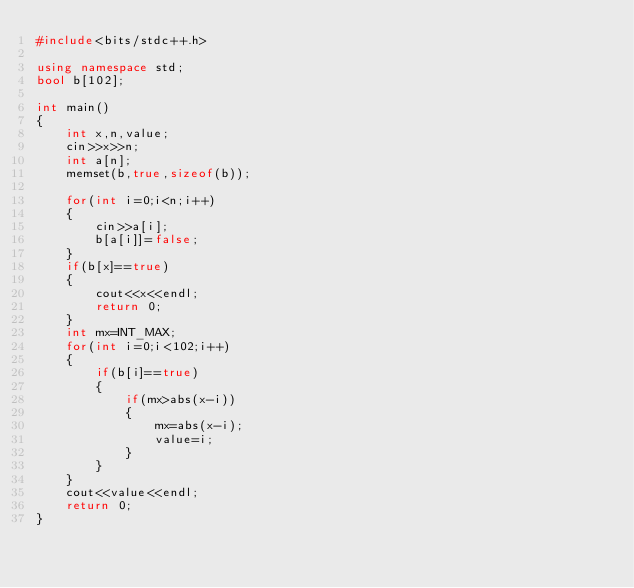<code> <loc_0><loc_0><loc_500><loc_500><_C++_>#include<bits/stdc++.h>

using namespace std;
bool b[102];

int main()
{
    int x,n,value;
    cin>>x>>n;
    int a[n];
    memset(b,true,sizeof(b));

    for(int i=0;i<n;i++)
    {
        cin>>a[i];
        b[a[i]]=false;
    }
    if(b[x]==true)
    {
        cout<<x<<endl;
        return 0;
    }
    int mx=INT_MAX;
    for(int i=0;i<102;i++)
    {
        if(b[i]==true)
        {
            if(mx>abs(x-i))
            {
                mx=abs(x-i);
                value=i;
            }
        }
    }
    cout<<value<<endl;
    return 0;
}
</code> 